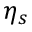<formula> <loc_0><loc_0><loc_500><loc_500>\eta _ { s }</formula> 